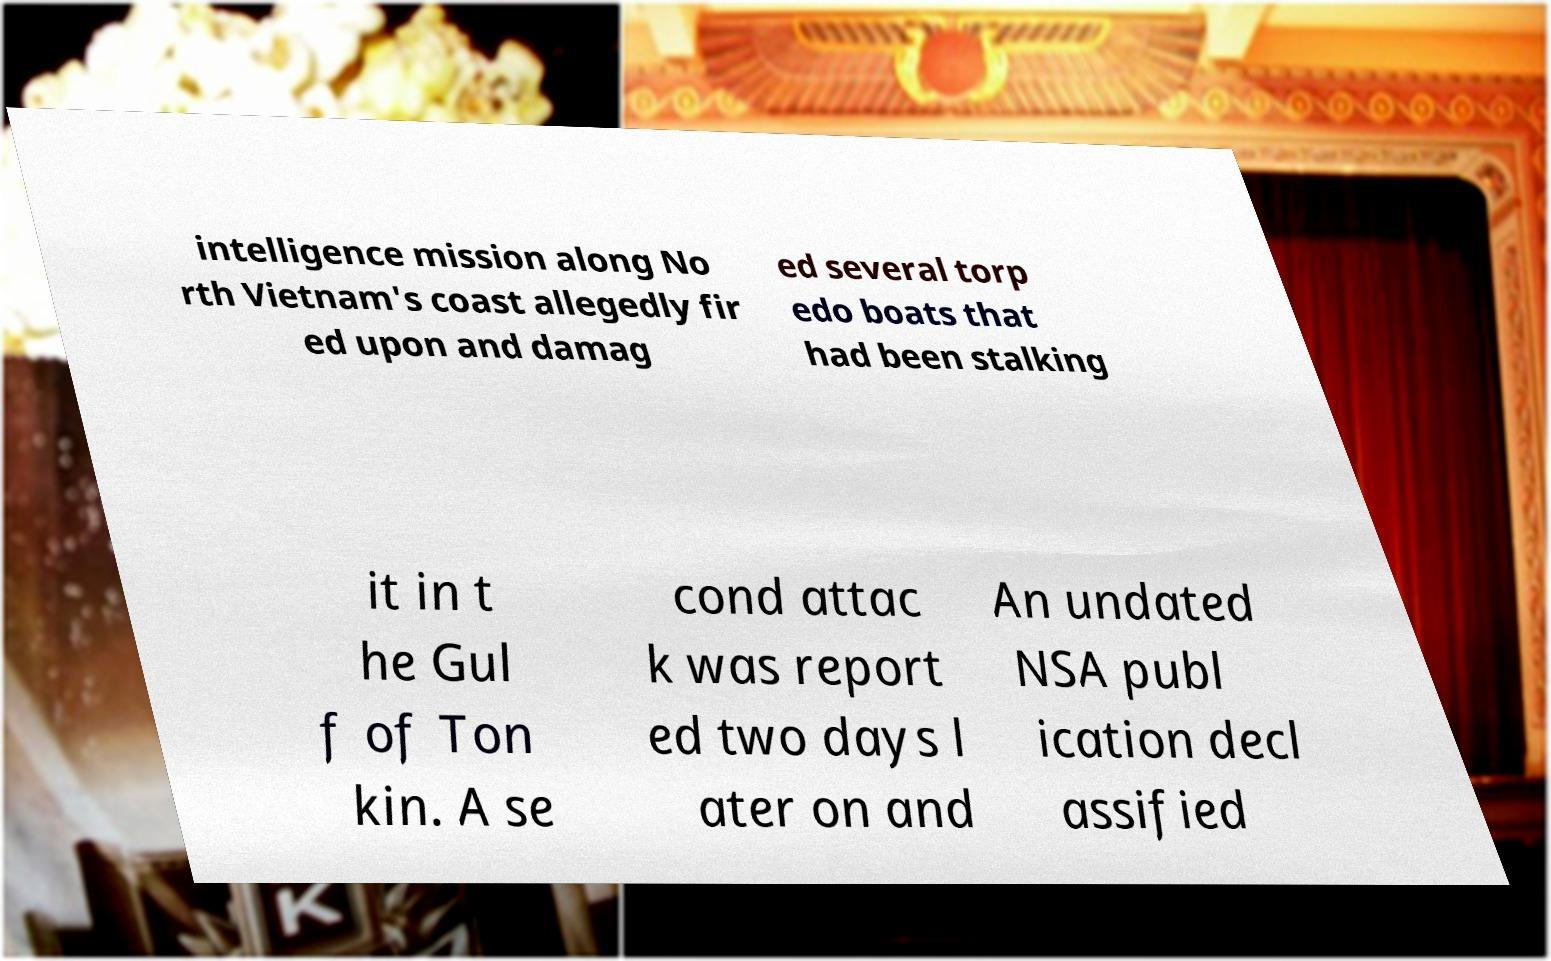There's text embedded in this image that I need extracted. Can you transcribe it verbatim? intelligence mission along No rth Vietnam's coast allegedly fir ed upon and damag ed several torp edo boats that had been stalking it in t he Gul f of Ton kin. A se cond attac k was report ed two days l ater on and An undated NSA publ ication decl assified 